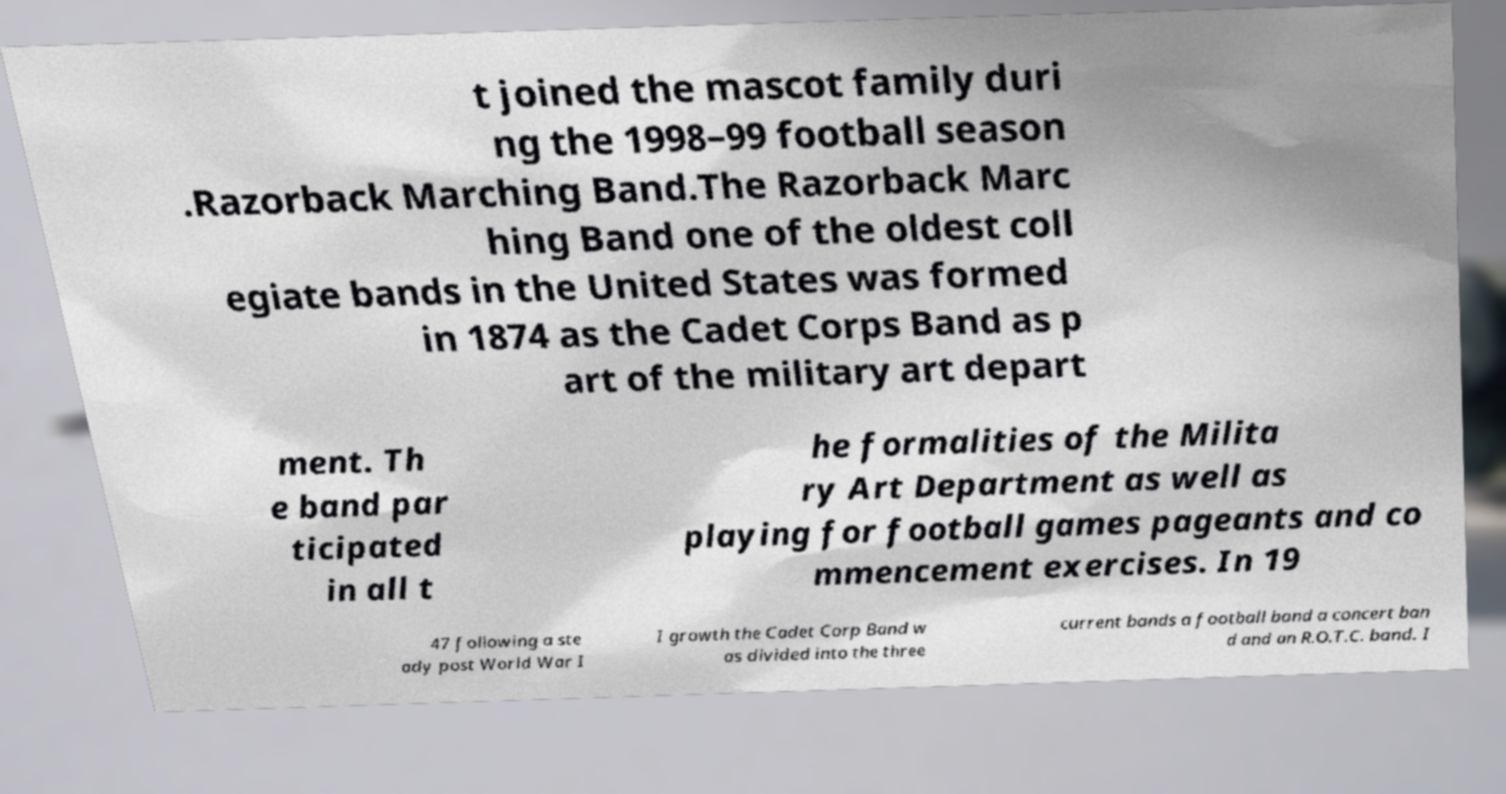Could you extract and type out the text from this image? t joined the mascot family duri ng the 1998–99 football season .Razorback Marching Band.The Razorback Marc hing Band one of the oldest coll egiate bands in the United States was formed in 1874 as the Cadet Corps Band as p art of the military art depart ment. Th e band par ticipated in all t he formalities of the Milita ry Art Department as well as playing for football games pageants and co mmencement exercises. In 19 47 following a ste ady post World War I I growth the Cadet Corp Band w as divided into the three current bands a football band a concert ban d and an R.O.T.C. band. I 